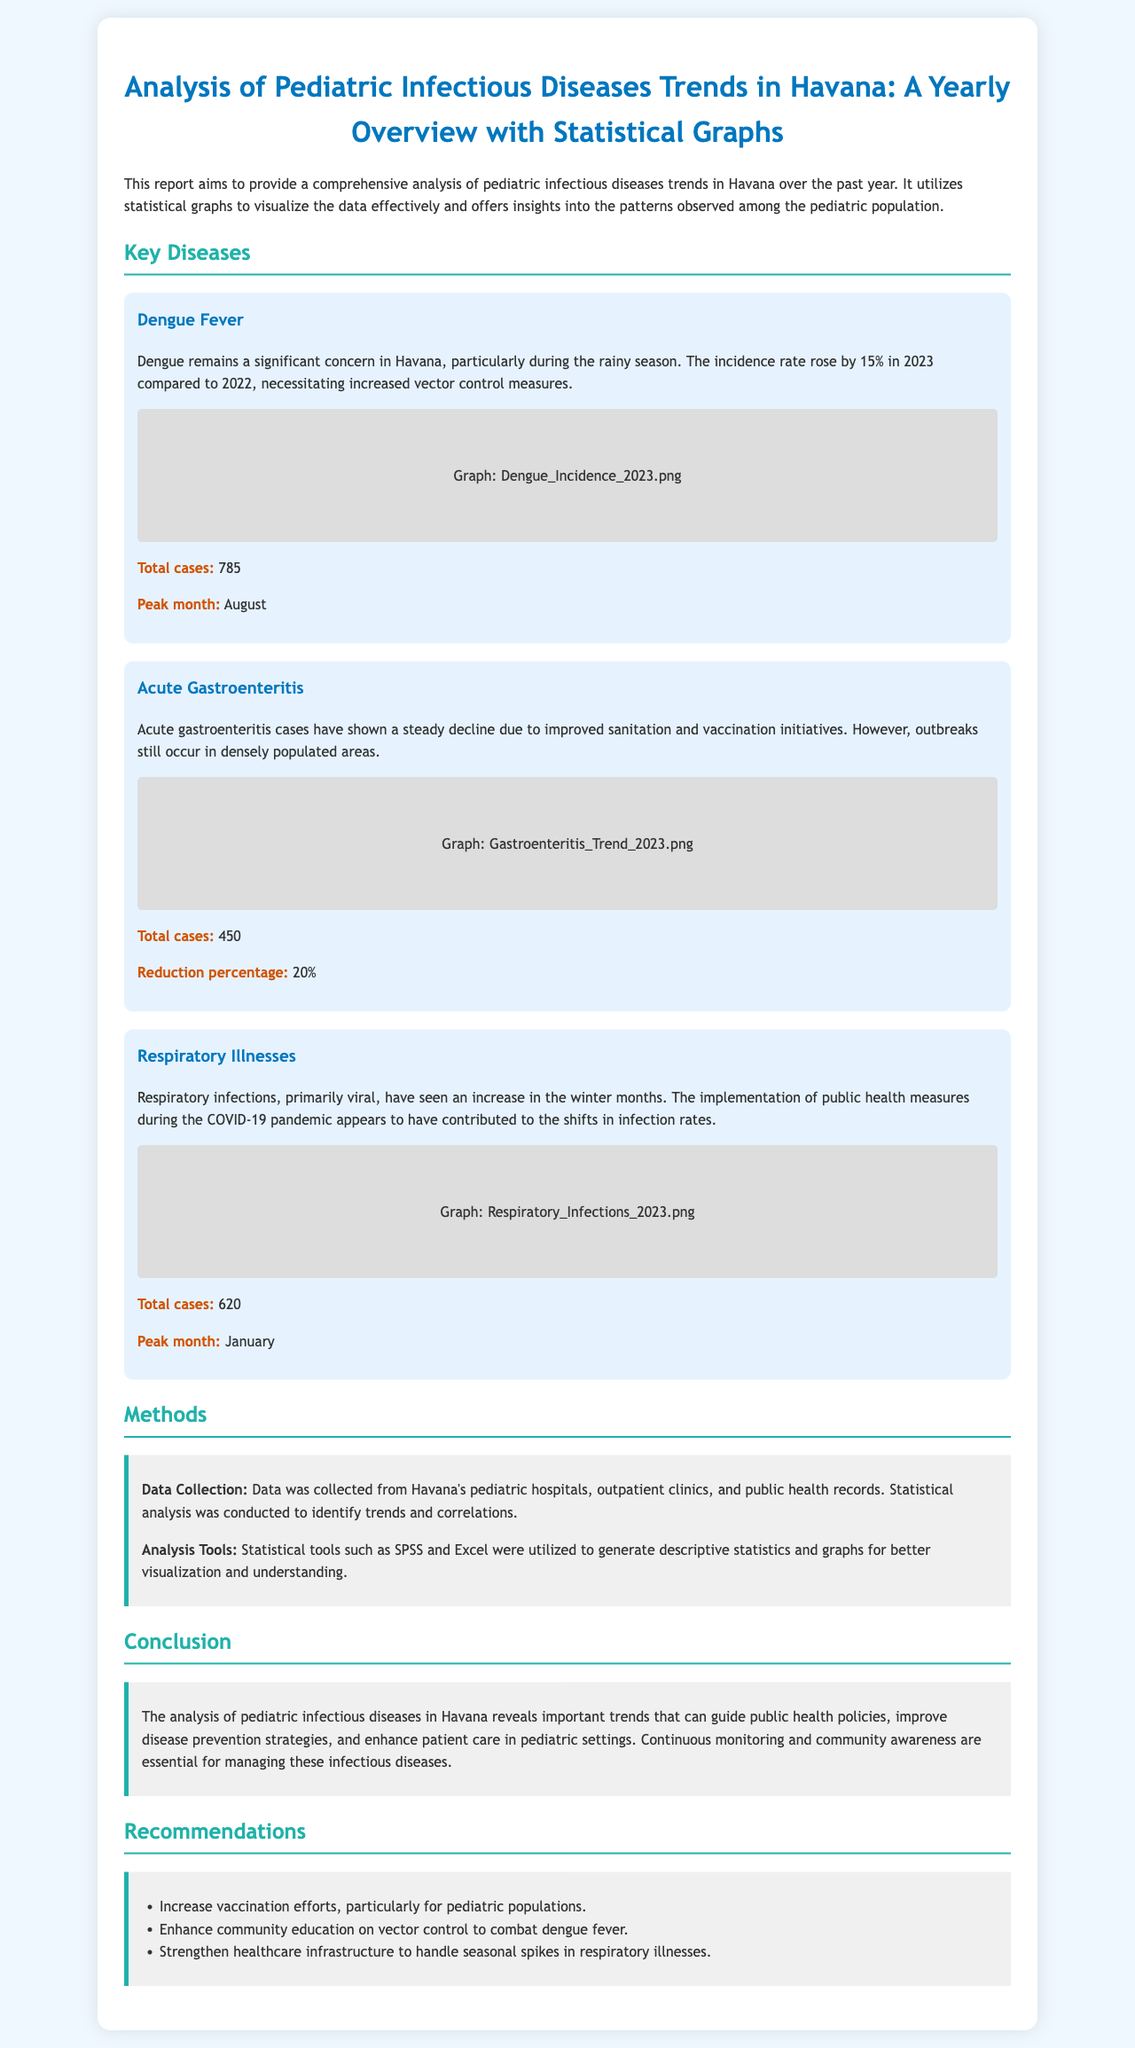What is the total number of Dengue Fever cases? The total number of Dengue Fever cases is explicitly mentioned as 785 in the document.
Answer: 785 What percentage reduction of Acute Gastroenteritis cases was observed? The document states that there was a 20% reduction in Acute Gastroenteritis cases.
Answer: 20% Which month recorded the peak incidence of Respiratory Illnesses? January is identified as the peak month for Respiratory Illnesses in the report.
Answer: January What is one of the key public health measures mentioned for managing Dengue Fever? The document emphasizes increasing vector control measures as a response to rising cases of Dengue Fever.
Answer: Vector control measures How was data collected for this report? The methods section outlines that data was collected from pediatric hospitals, outpatient clinics, and public health records.
Answer: Pediatric hospitals, outpatient clinics, and public health records What tool was used for statistical analysis in the report? SPSS is mentioned as one of the tools utilized for statistical analysis in the report.
Answer: SPSS Which disease shows an increase during the winter months? The report specifically mentions that Respiratory Illnesses have seen an increase in the winter months.
Answer: Respiratory Illnesses What was the primary reason for the decline in Acute Gastroenteritis cases? The report attributes the decline in Acute Gastroenteritis cases to improved sanitation and vaccination initiatives.
Answer: Improved sanitation and vaccination initiatives 